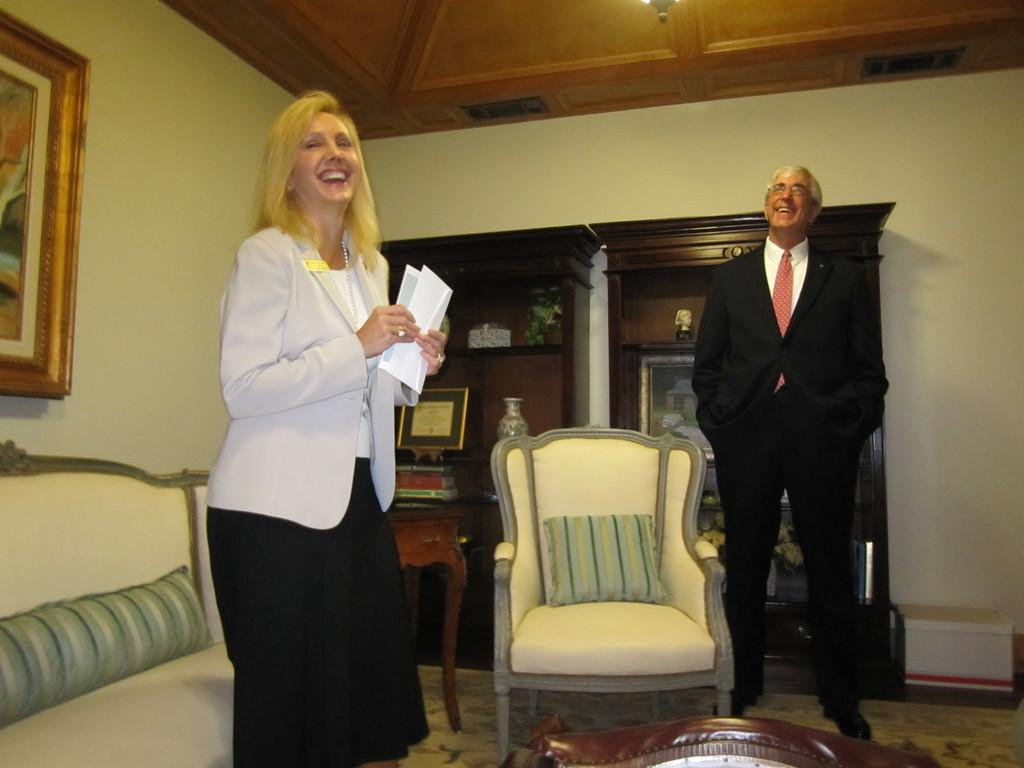How many people are in the room in the image? There are two people in the room in the image. Can you describe the gender of the people? One person is a man, and the other person is a woman. What are the people doing in the image? The two people are standing. What furniture is present in the room? There are chairs, a table, and a cupboard in the room. What can be seen in the background of the image? There is a wall in the background. What type of can is visible on the table in the image? There is no can visible on the table in the image. What kind of bubble can be seen floating near the ceiling in the image? There are no bubbles present in the image. 